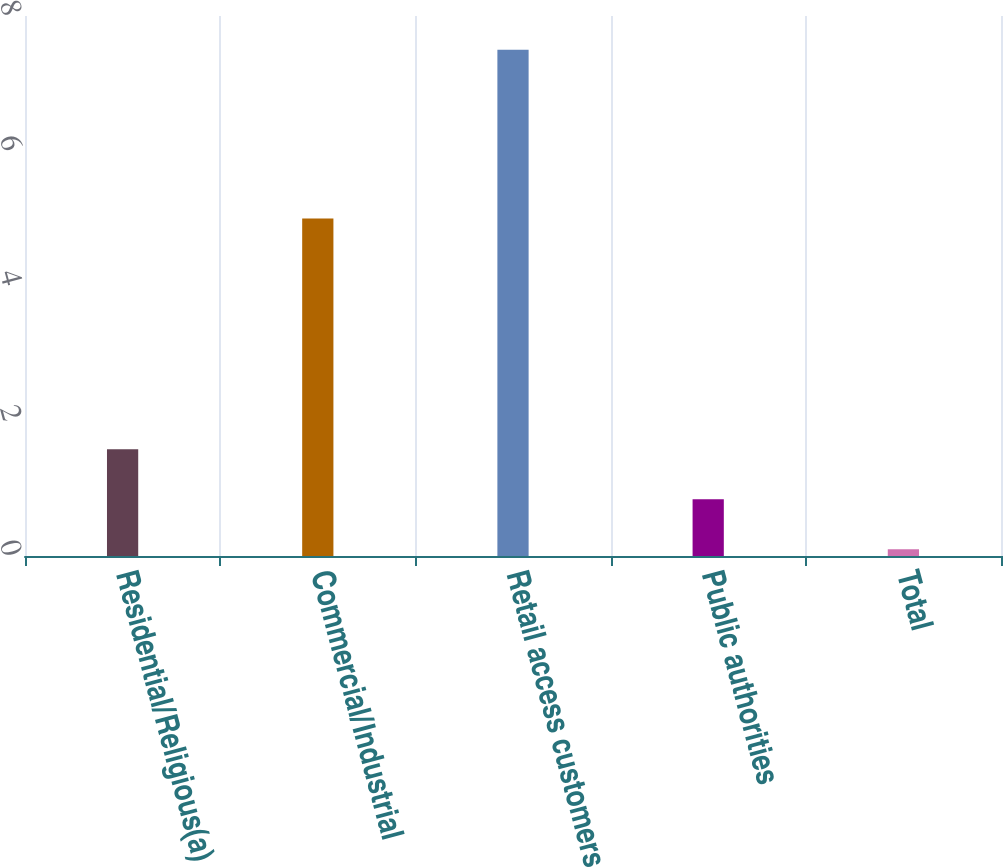Convert chart. <chart><loc_0><loc_0><loc_500><loc_500><bar_chart><fcel>Residential/Religious(a)<fcel>Commercial/Industrial<fcel>Retail access customers<fcel>Public authorities<fcel>Total<nl><fcel>1.58<fcel>5<fcel>7.5<fcel>0.84<fcel>0.1<nl></chart> 